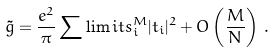Convert formula to latex. <formula><loc_0><loc_0><loc_500><loc_500>\tilde { g } = \frac { e ^ { 2 } } { \pi } \sum \lim i t s _ { i } ^ { M } | t _ { i } | ^ { 2 } + O \left ( \frac { M } { N } \right ) \, .</formula> 